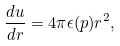<formula> <loc_0><loc_0><loc_500><loc_500>\frac { d u } { d r } = 4 \pi \epsilon ( p ) r ^ { 2 } ,</formula> 